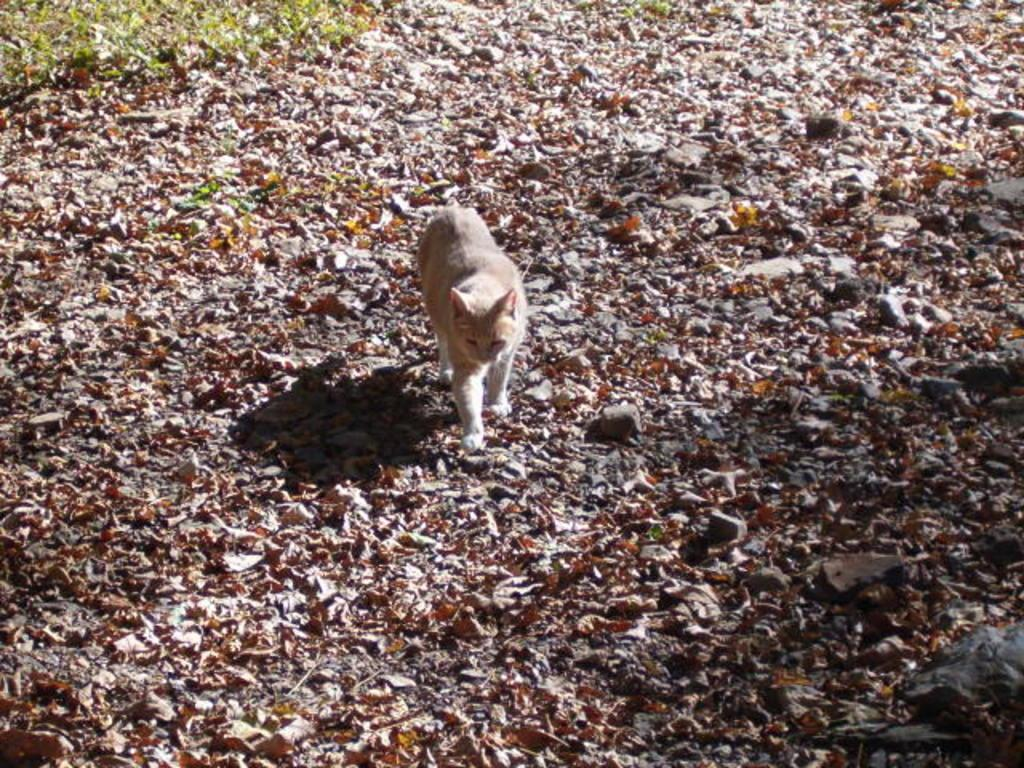What type of animal can be seen on the ground in the image? There is a cat on the ground in the image. What else is present on the ground besides the cat? There are dried leaves and stones on the ground. How is the grass depicted in the image? The grass is truncated towards the left side of the image. What type of mine is visible in the image? There is no mine present in the image; it features a cat, dried leaves, stones, and grass. What position is the cat in the image? The position of the cat cannot be determined from the image alone, as it only shows the cat on the ground without any specific posture or orientation. 